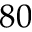Convert formula to latex. <formula><loc_0><loc_0><loc_500><loc_500>8 0</formula> 